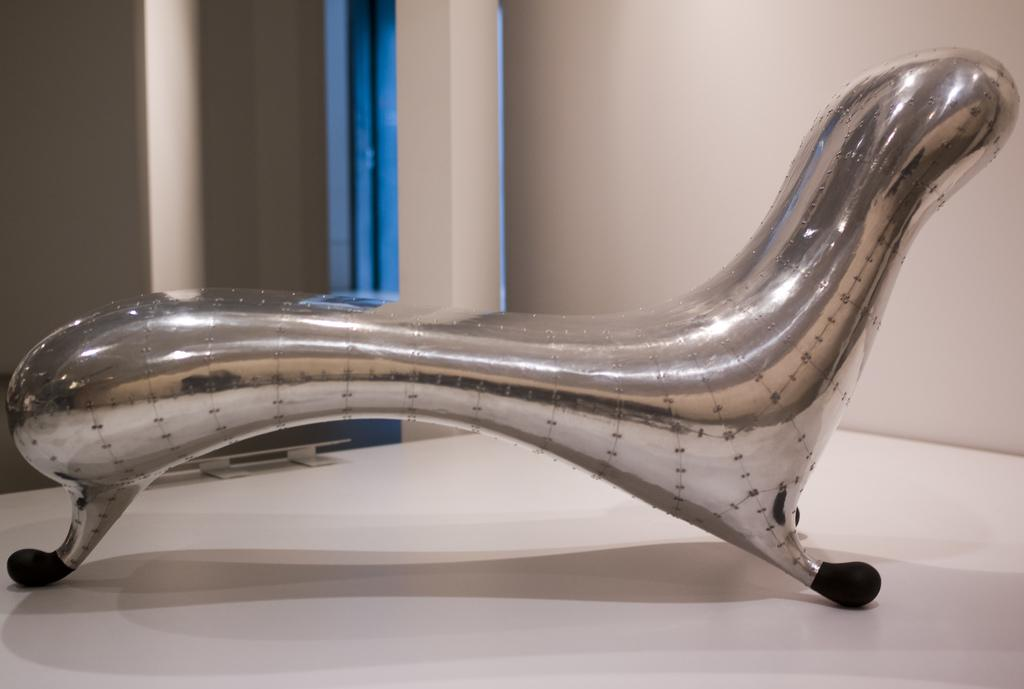What type of chair is in the image? There is a silver chair in the image. What is visible in the background of the image? There is a wall and a pillar in the background of the image. What type of waste is visible on the floor in the image? There is no waste visible on the floor in the image. Can you tell me how many girls are present in the image? There is no girl present in the image. 